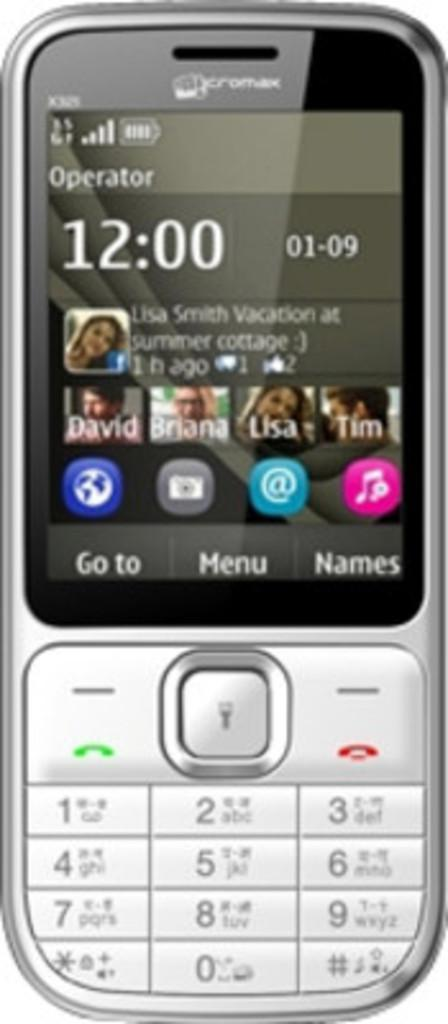<image>
Offer a succinct explanation of the picture presented. David and Tim are two guys that listed as contacts on the phone. 